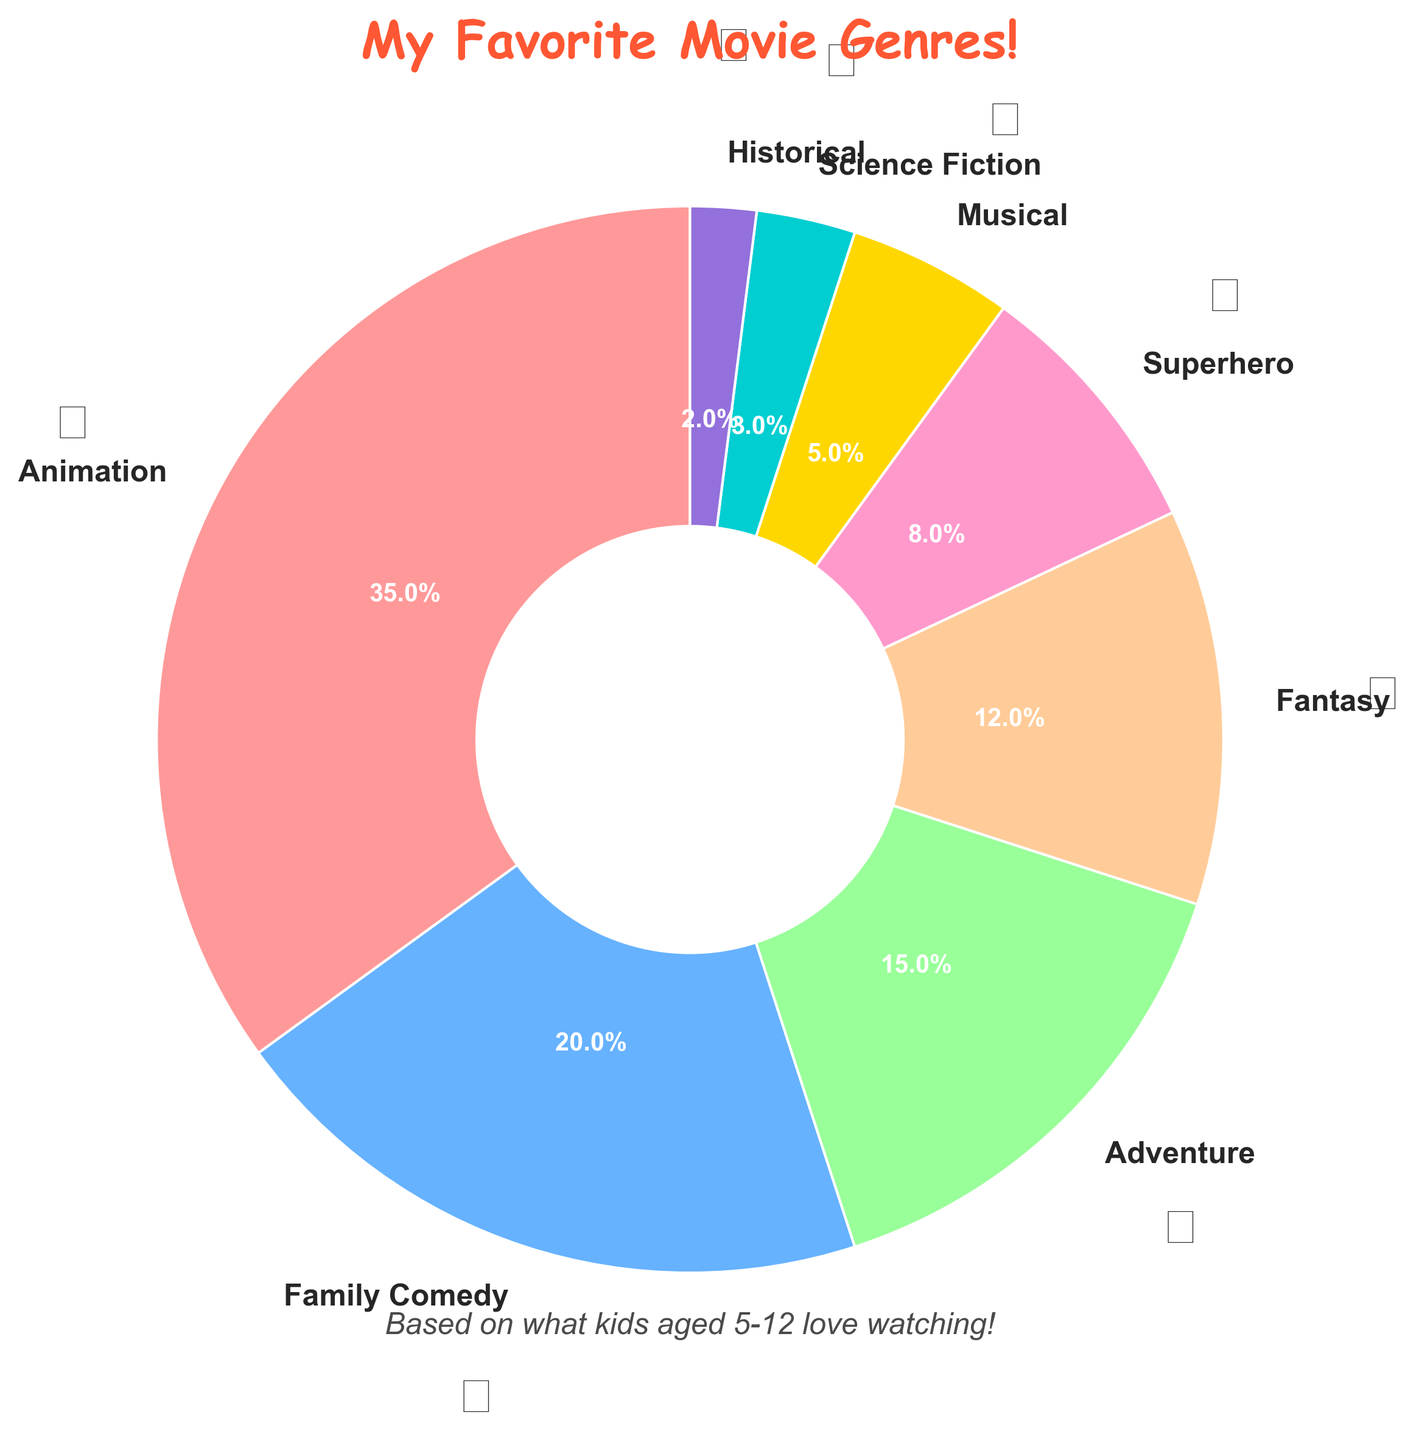What's the most favorite movie genre among children aged 5-12? Look at the segment of the pie chart with the largest percentage. The "Animation" genre has the largest segment.
Answer: Animation Which genre is less popular, Adventure or Superhero? Compare the percentages for Adventure and Superhero. Adventure has 15% while Superhero has 8%.
Answer: Superhero What is the total percentage of children who prefer Family Comedy and Fantasy combined? Add the percentages of Family Comedy and Fantasy. Family Comedy is 20% and Fantasy is 12%. Thus, 20 + 12 = 32%.
Answer: 32% How much more popular is Animation compared to Musical among children in the chart? Subtract the percentage of Musical from Animation. Animation is 35%, and Musical is 5%. Thus, 35 - 5 = 30%.
Answer: 30% Are there more children who like Superhero movies than those who like Science Fiction? Compare the percentages of Superhero and Science Fiction. Superhero has 8%, while Science Fiction has 3%.
Answer: Yes Which genre has the smallest percentage of preference among children aged 5-12? Check the segment of the pie chart with the smallest percentage. The "Historical" genre has the smallest segment.
Answer: Historical If you combine Musical and Science Fiction, would their combined percentage be greater than Adventure? Add the percentages of Musical and Science Fiction, and compare with Adventure. Musical is 5% and Science Fiction is 3%, thus 5 + 3 = 8%, which is less than Adventure's 15%.
Answer: No Which is more popular: Family Comedy or Fantasy? By how much? Compare the percentages of Family Comedy and Fantasy. Family Comedy is 20% and Fantasy is 12%. Thus, Family Comedy is more popular by 20 - 12 = 8%.
Answer: Family Comedy by 8% What is the percentage difference between Adventure and Superhero genres? Subtract the percentage of Superhero from Adventure. Adventure is 15%, Superhero is 8%. Thus, 15 - 8 = 7%.
Answer: 7% Which genre is represented by the blue segment in the pie chart? Look at the legend of the pie chart to find the color representation of genres. "Family Comedy" is represented by the blue segment.
Answer: Family Comedy 